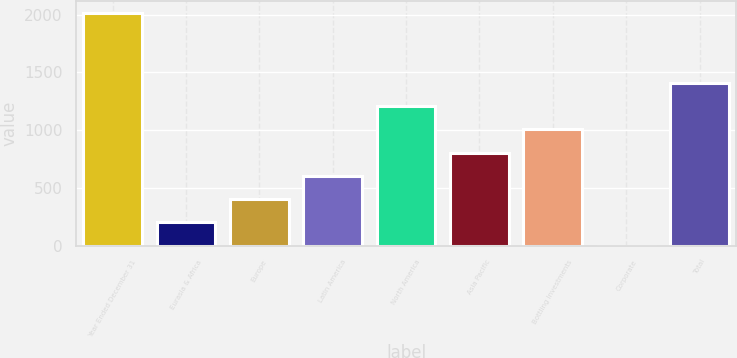Convert chart to OTSL. <chart><loc_0><loc_0><loc_500><loc_500><bar_chart><fcel>Year Ended December 31<fcel>Eurasia & Africa<fcel>Europe<fcel>Latin America<fcel>North America<fcel>Asia Pacific<fcel>Bottling Investments<fcel>Corporate<fcel>Total<nl><fcel>2013<fcel>201.57<fcel>402.84<fcel>604.11<fcel>1207.92<fcel>805.38<fcel>1006.65<fcel>0.3<fcel>1409.19<nl></chart> 